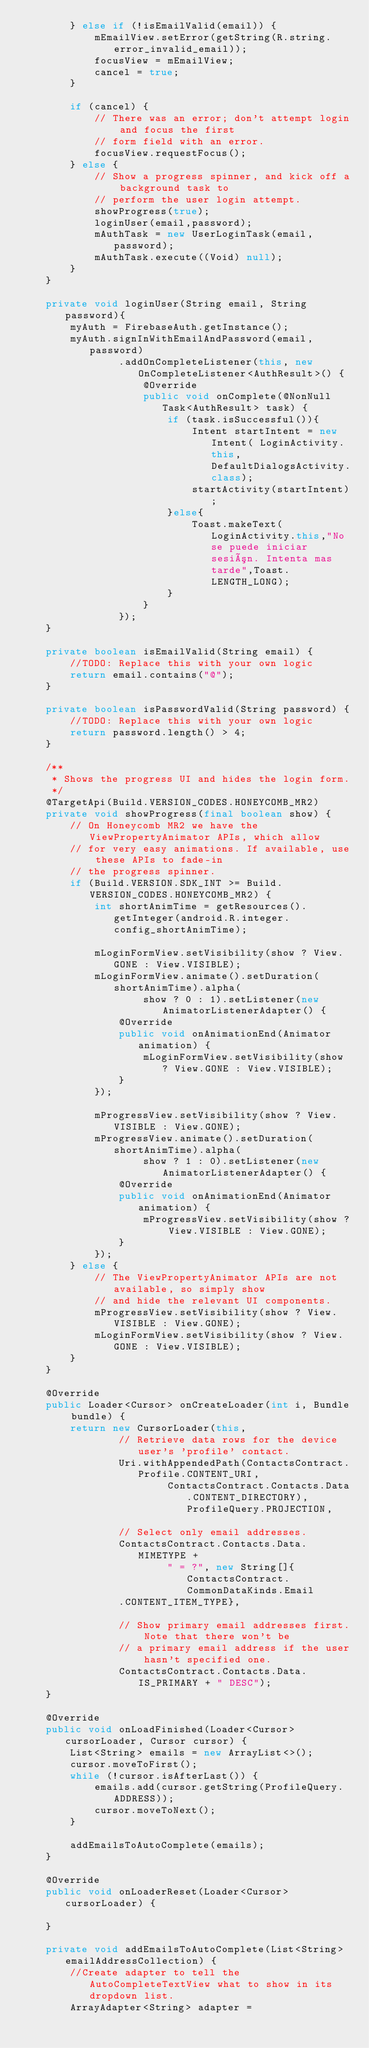<code> <loc_0><loc_0><loc_500><loc_500><_Java_>        } else if (!isEmailValid(email)) {
            mEmailView.setError(getString(R.string.error_invalid_email));
            focusView = mEmailView;
            cancel = true;
        }

        if (cancel) {
            // There was an error; don't attempt login and focus the first
            // form field with an error.
            focusView.requestFocus();
        } else {
            // Show a progress spinner, and kick off a background task to
            // perform the user login attempt.
            showProgress(true);
            loginUser(email,password);
            mAuthTask = new UserLoginTask(email, password);
            mAuthTask.execute((Void) null);
        }
    }

    private void loginUser(String email, String password){
        myAuth = FirebaseAuth.getInstance();
        myAuth.signInWithEmailAndPassword(email,password)
                .addOnCompleteListener(this, new OnCompleteListener<AuthResult>() {
                    @Override
                    public void onComplete(@NonNull Task<AuthResult> task) {
                        if (task.isSuccessful()){
                            Intent startIntent = new Intent( LoginActivity.this,DefaultDialogsActivity.class);
                            startActivity(startIntent);
                        }else{
                            Toast.makeText(LoginActivity.this,"No se puede iniciar sesión. Intenta mas tarde",Toast.LENGTH_LONG);
                        }
                    }
                });
    }

    private boolean isEmailValid(String email) {
        //TODO: Replace this with your own logic
        return email.contains("@");
    }

    private boolean isPasswordValid(String password) {
        //TODO: Replace this with your own logic
        return password.length() > 4;
    }

    /**
     * Shows the progress UI and hides the login form.
     */
    @TargetApi(Build.VERSION_CODES.HONEYCOMB_MR2)
    private void showProgress(final boolean show) {
        // On Honeycomb MR2 we have the ViewPropertyAnimator APIs, which allow
        // for very easy animations. If available, use these APIs to fade-in
        // the progress spinner.
        if (Build.VERSION.SDK_INT >= Build.VERSION_CODES.HONEYCOMB_MR2) {
            int shortAnimTime = getResources().getInteger(android.R.integer.config_shortAnimTime);

            mLoginFormView.setVisibility(show ? View.GONE : View.VISIBLE);
            mLoginFormView.animate().setDuration(shortAnimTime).alpha(
                    show ? 0 : 1).setListener(new AnimatorListenerAdapter() {
                @Override
                public void onAnimationEnd(Animator animation) {
                    mLoginFormView.setVisibility(show ? View.GONE : View.VISIBLE);
                }
            });

            mProgressView.setVisibility(show ? View.VISIBLE : View.GONE);
            mProgressView.animate().setDuration(shortAnimTime).alpha(
                    show ? 1 : 0).setListener(new AnimatorListenerAdapter() {
                @Override
                public void onAnimationEnd(Animator animation) {
                    mProgressView.setVisibility(show ? View.VISIBLE : View.GONE);
                }
            });
        } else {
            // The ViewPropertyAnimator APIs are not available, so simply show
            // and hide the relevant UI components.
            mProgressView.setVisibility(show ? View.VISIBLE : View.GONE);
            mLoginFormView.setVisibility(show ? View.GONE : View.VISIBLE);
        }
    }

    @Override
    public Loader<Cursor> onCreateLoader(int i, Bundle bundle) {
        return new CursorLoader(this,
                // Retrieve data rows for the device user's 'profile' contact.
                Uri.withAppendedPath(ContactsContract.Profile.CONTENT_URI,
                        ContactsContract.Contacts.Data.CONTENT_DIRECTORY), ProfileQuery.PROJECTION,

                // Select only email addresses.
                ContactsContract.Contacts.Data.MIMETYPE +
                        " = ?", new String[]{ContactsContract.CommonDataKinds.Email
                .CONTENT_ITEM_TYPE},

                // Show primary email addresses first. Note that there won't be
                // a primary email address if the user hasn't specified one.
                ContactsContract.Contacts.Data.IS_PRIMARY + " DESC");
    }

    @Override
    public void onLoadFinished(Loader<Cursor> cursorLoader, Cursor cursor) {
        List<String> emails = new ArrayList<>();
        cursor.moveToFirst();
        while (!cursor.isAfterLast()) {
            emails.add(cursor.getString(ProfileQuery.ADDRESS));
            cursor.moveToNext();
        }

        addEmailsToAutoComplete(emails);
    }

    @Override
    public void onLoaderReset(Loader<Cursor> cursorLoader) {

    }

    private void addEmailsToAutoComplete(List<String> emailAddressCollection) {
        //Create adapter to tell the AutoCompleteTextView what to show in its dropdown list.
        ArrayAdapter<String> adapter =</code> 